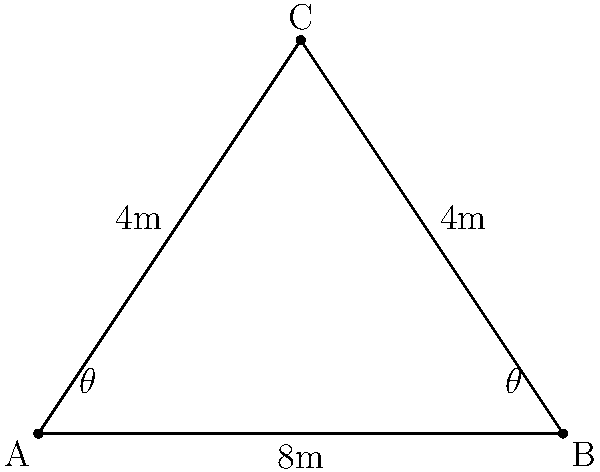A cleaning robot needs to travel from point A to point C and then to point B in a triangular room. The distance from A to B is 8 meters, and both AC and BC are 4 meters. What angle $\theta$ should the robot turn at point A to follow the most efficient path (AC + CB) to cover all points? To find the most efficient path, we need to determine the angle $\theta$ that the robot should turn at point A. We can solve this using the following steps:

1) First, we recognize that the triangle is isosceles, with AC = BC = 4m.

2) We can split the triangle into two right triangles by drawing a line from C perpendicular to AB.

3) In one of these right triangles:
   - The hypotenuse is 4m (AC or BC)
   - Half of the base is 4m (half of AB)

4) We can use the cosine function to find $\theta$:

   $$\cos \theta = \frac{\text{adjacent}}{\text{hypotenuse}} = \frac{4}{4} = 1$$

5) Taking the inverse cosine (arccos) of both sides:

   $$\theta = \arccos(1) = 0$$

6) However, this is the angle between the robot's path and the perpendicular line from C to AB. We need the angle between the robot's path and AB.

7) The angle we're looking for is the complement of this angle:

   $$90° - 0° = 90°$$

Therefore, the robot should turn 90° at point A to follow the most efficient path.
Answer: 90° 